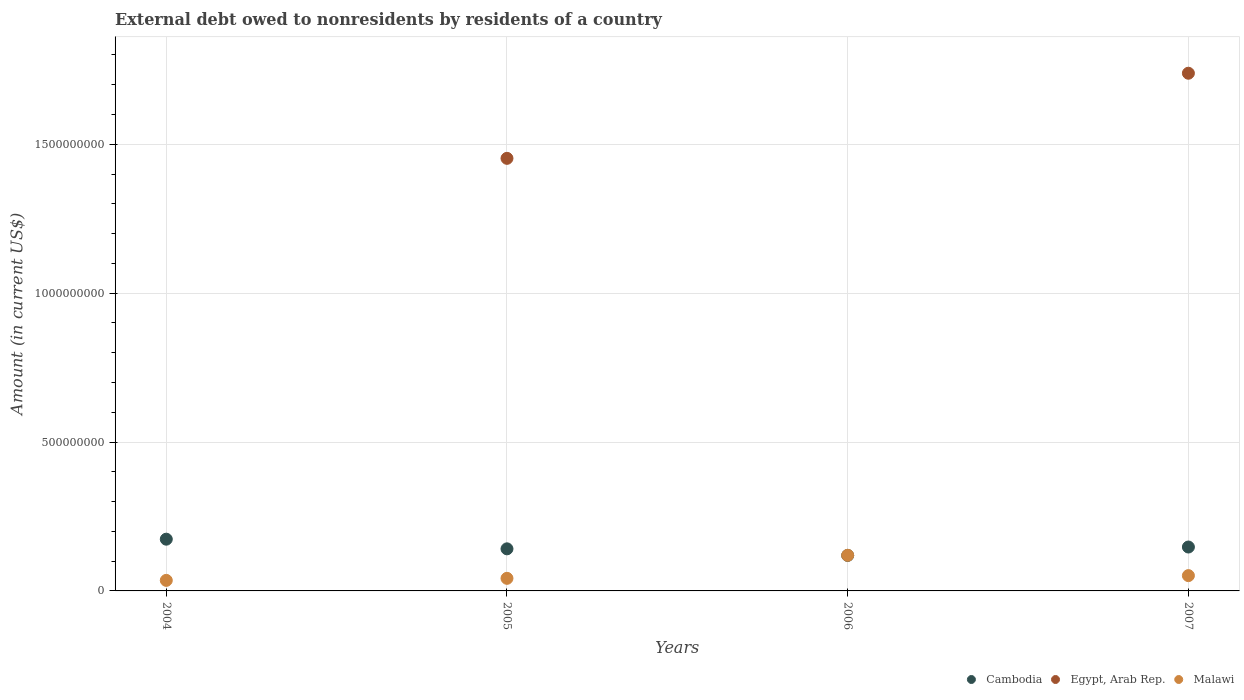What is the external debt owed by residents in Egypt, Arab Rep. in 2007?
Offer a very short reply. 1.74e+09. Across all years, what is the maximum external debt owed by residents in Malawi?
Give a very brief answer. 1.20e+08. Across all years, what is the minimum external debt owed by residents in Cambodia?
Offer a very short reply. 1.19e+08. In which year was the external debt owed by residents in Egypt, Arab Rep. maximum?
Your response must be concise. 2007. What is the total external debt owed by residents in Egypt, Arab Rep. in the graph?
Offer a very short reply. 3.19e+09. What is the difference between the external debt owed by residents in Cambodia in 2006 and that in 2007?
Offer a very short reply. -2.82e+07. What is the difference between the external debt owed by residents in Egypt, Arab Rep. in 2005 and the external debt owed by residents in Malawi in 2007?
Your answer should be compact. 1.40e+09. What is the average external debt owed by residents in Egypt, Arab Rep. per year?
Offer a very short reply. 7.98e+08. In the year 2007, what is the difference between the external debt owed by residents in Egypt, Arab Rep. and external debt owed by residents in Malawi?
Provide a succinct answer. 1.69e+09. In how many years, is the external debt owed by residents in Egypt, Arab Rep. greater than 1200000000 US$?
Your response must be concise. 2. What is the ratio of the external debt owed by residents in Malawi in 2006 to that in 2007?
Ensure brevity in your answer.  2.33. Is the external debt owed by residents in Cambodia in 2005 less than that in 2006?
Give a very brief answer. No. What is the difference between the highest and the second highest external debt owed by residents in Cambodia?
Your answer should be very brief. 2.63e+07. What is the difference between the highest and the lowest external debt owed by residents in Cambodia?
Make the answer very short. 5.45e+07. Is the sum of the external debt owed by residents in Cambodia in 2004 and 2005 greater than the maximum external debt owed by residents in Egypt, Arab Rep. across all years?
Your answer should be very brief. No. Does the external debt owed by residents in Malawi monotonically increase over the years?
Offer a terse response. No. How many dotlines are there?
Your answer should be compact. 3. What is the difference between two consecutive major ticks on the Y-axis?
Provide a short and direct response. 5.00e+08. Does the graph contain any zero values?
Offer a terse response. Yes. Does the graph contain grids?
Make the answer very short. Yes. Where does the legend appear in the graph?
Ensure brevity in your answer.  Bottom right. How many legend labels are there?
Give a very brief answer. 3. What is the title of the graph?
Provide a succinct answer. External debt owed to nonresidents by residents of a country. Does "Samoa" appear as one of the legend labels in the graph?
Ensure brevity in your answer.  No. What is the label or title of the X-axis?
Provide a succinct answer. Years. What is the Amount (in current US$) in Cambodia in 2004?
Make the answer very short. 1.74e+08. What is the Amount (in current US$) in Egypt, Arab Rep. in 2004?
Make the answer very short. 0. What is the Amount (in current US$) of Malawi in 2004?
Provide a short and direct response. 3.54e+07. What is the Amount (in current US$) of Cambodia in 2005?
Offer a very short reply. 1.41e+08. What is the Amount (in current US$) of Egypt, Arab Rep. in 2005?
Your answer should be very brief. 1.45e+09. What is the Amount (in current US$) of Malawi in 2005?
Give a very brief answer. 4.23e+07. What is the Amount (in current US$) in Cambodia in 2006?
Ensure brevity in your answer.  1.19e+08. What is the Amount (in current US$) of Malawi in 2006?
Provide a succinct answer. 1.20e+08. What is the Amount (in current US$) in Cambodia in 2007?
Offer a very short reply. 1.47e+08. What is the Amount (in current US$) in Egypt, Arab Rep. in 2007?
Your answer should be very brief. 1.74e+09. What is the Amount (in current US$) of Malawi in 2007?
Your response must be concise. 5.14e+07. Across all years, what is the maximum Amount (in current US$) in Cambodia?
Your response must be concise. 1.74e+08. Across all years, what is the maximum Amount (in current US$) in Egypt, Arab Rep.?
Offer a very short reply. 1.74e+09. Across all years, what is the maximum Amount (in current US$) in Malawi?
Your answer should be very brief. 1.20e+08. Across all years, what is the minimum Amount (in current US$) in Cambodia?
Give a very brief answer. 1.19e+08. Across all years, what is the minimum Amount (in current US$) in Egypt, Arab Rep.?
Give a very brief answer. 0. Across all years, what is the minimum Amount (in current US$) in Malawi?
Offer a very short reply. 3.54e+07. What is the total Amount (in current US$) of Cambodia in the graph?
Provide a short and direct response. 5.82e+08. What is the total Amount (in current US$) of Egypt, Arab Rep. in the graph?
Your answer should be very brief. 3.19e+09. What is the total Amount (in current US$) in Malawi in the graph?
Make the answer very short. 2.49e+08. What is the difference between the Amount (in current US$) of Cambodia in 2004 and that in 2005?
Provide a succinct answer. 3.24e+07. What is the difference between the Amount (in current US$) of Malawi in 2004 and that in 2005?
Offer a very short reply. -6.87e+06. What is the difference between the Amount (in current US$) of Cambodia in 2004 and that in 2006?
Provide a short and direct response. 5.45e+07. What is the difference between the Amount (in current US$) in Malawi in 2004 and that in 2006?
Your response must be concise. -8.43e+07. What is the difference between the Amount (in current US$) in Cambodia in 2004 and that in 2007?
Make the answer very short. 2.63e+07. What is the difference between the Amount (in current US$) in Malawi in 2004 and that in 2007?
Give a very brief answer. -1.60e+07. What is the difference between the Amount (in current US$) in Cambodia in 2005 and that in 2006?
Your answer should be compact. 2.21e+07. What is the difference between the Amount (in current US$) in Malawi in 2005 and that in 2006?
Provide a succinct answer. -7.74e+07. What is the difference between the Amount (in current US$) in Cambodia in 2005 and that in 2007?
Keep it short and to the point. -6.06e+06. What is the difference between the Amount (in current US$) in Egypt, Arab Rep. in 2005 and that in 2007?
Your response must be concise. -2.86e+08. What is the difference between the Amount (in current US$) of Malawi in 2005 and that in 2007?
Your answer should be very brief. -9.10e+06. What is the difference between the Amount (in current US$) in Cambodia in 2006 and that in 2007?
Make the answer very short. -2.82e+07. What is the difference between the Amount (in current US$) of Malawi in 2006 and that in 2007?
Give a very brief answer. 6.83e+07. What is the difference between the Amount (in current US$) of Cambodia in 2004 and the Amount (in current US$) of Egypt, Arab Rep. in 2005?
Offer a very short reply. -1.28e+09. What is the difference between the Amount (in current US$) in Cambodia in 2004 and the Amount (in current US$) in Malawi in 2005?
Your response must be concise. 1.31e+08. What is the difference between the Amount (in current US$) in Cambodia in 2004 and the Amount (in current US$) in Malawi in 2006?
Give a very brief answer. 5.41e+07. What is the difference between the Amount (in current US$) in Cambodia in 2004 and the Amount (in current US$) in Egypt, Arab Rep. in 2007?
Make the answer very short. -1.56e+09. What is the difference between the Amount (in current US$) in Cambodia in 2004 and the Amount (in current US$) in Malawi in 2007?
Provide a short and direct response. 1.22e+08. What is the difference between the Amount (in current US$) of Cambodia in 2005 and the Amount (in current US$) of Malawi in 2006?
Make the answer very short. 2.17e+07. What is the difference between the Amount (in current US$) of Egypt, Arab Rep. in 2005 and the Amount (in current US$) of Malawi in 2006?
Your answer should be compact. 1.33e+09. What is the difference between the Amount (in current US$) in Cambodia in 2005 and the Amount (in current US$) in Egypt, Arab Rep. in 2007?
Your answer should be very brief. -1.60e+09. What is the difference between the Amount (in current US$) in Cambodia in 2005 and the Amount (in current US$) in Malawi in 2007?
Offer a terse response. 9.00e+07. What is the difference between the Amount (in current US$) of Egypt, Arab Rep. in 2005 and the Amount (in current US$) of Malawi in 2007?
Offer a terse response. 1.40e+09. What is the difference between the Amount (in current US$) of Cambodia in 2006 and the Amount (in current US$) of Egypt, Arab Rep. in 2007?
Your response must be concise. -1.62e+09. What is the difference between the Amount (in current US$) in Cambodia in 2006 and the Amount (in current US$) in Malawi in 2007?
Give a very brief answer. 6.78e+07. What is the average Amount (in current US$) in Cambodia per year?
Keep it short and to the point. 1.45e+08. What is the average Amount (in current US$) of Egypt, Arab Rep. per year?
Offer a terse response. 7.98e+08. What is the average Amount (in current US$) in Malawi per year?
Your answer should be compact. 6.22e+07. In the year 2004, what is the difference between the Amount (in current US$) in Cambodia and Amount (in current US$) in Malawi?
Your answer should be compact. 1.38e+08. In the year 2005, what is the difference between the Amount (in current US$) of Cambodia and Amount (in current US$) of Egypt, Arab Rep.?
Offer a terse response. -1.31e+09. In the year 2005, what is the difference between the Amount (in current US$) of Cambodia and Amount (in current US$) of Malawi?
Your response must be concise. 9.91e+07. In the year 2005, what is the difference between the Amount (in current US$) in Egypt, Arab Rep. and Amount (in current US$) in Malawi?
Offer a very short reply. 1.41e+09. In the year 2006, what is the difference between the Amount (in current US$) in Cambodia and Amount (in current US$) in Malawi?
Your answer should be very brief. -4.47e+05. In the year 2007, what is the difference between the Amount (in current US$) in Cambodia and Amount (in current US$) in Egypt, Arab Rep.?
Your answer should be very brief. -1.59e+09. In the year 2007, what is the difference between the Amount (in current US$) of Cambodia and Amount (in current US$) of Malawi?
Your answer should be very brief. 9.60e+07. In the year 2007, what is the difference between the Amount (in current US$) of Egypt, Arab Rep. and Amount (in current US$) of Malawi?
Your answer should be compact. 1.69e+09. What is the ratio of the Amount (in current US$) in Cambodia in 2004 to that in 2005?
Keep it short and to the point. 1.23. What is the ratio of the Amount (in current US$) of Malawi in 2004 to that in 2005?
Your response must be concise. 0.84. What is the ratio of the Amount (in current US$) of Cambodia in 2004 to that in 2006?
Keep it short and to the point. 1.46. What is the ratio of the Amount (in current US$) of Malawi in 2004 to that in 2006?
Provide a succinct answer. 0.3. What is the ratio of the Amount (in current US$) of Cambodia in 2004 to that in 2007?
Provide a short and direct response. 1.18. What is the ratio of the Amount (in current US$) in Malawi in 2004 to that in 2007?
Your answer should be compact. 0.69. What is the ratio of the Amount (in current US$) of Cambodia in 2005 to that in 2006?
Your answer should be compact. 1.19. What is the ratio of the Amount (in current US$) in Malawi in 2005 to that in 2006?
Provide a short and direct response. 0.35. What is the ratio of the Amount (in current US$) in Cambodia in 2005 to that in 2007?
Offer a very short reply. 0.96. What is the ratio of the Amount (in current US$) of Egypt, Arab Rep. in 2005 to that in 2007?
Provide a short and direct response. 0.84. What is the ratio of the Amount (in current US$) in Malawi in 2005 to that in 2007?
Offer a terse response. 0.82. What is the ratio of the Amount (in current US$) in Cambodia in 2006 to that in 2007?
Give a very brief answer. 0.81. What is the ratio of the Amount (in current US$) of Malawi in 2006 to that in 2007?
Provide a succinct answer. 2.33. What is the difference between the highest and the second highest Amount (in current US$) in Cambodia?
Keep it short and to the point. 2.63e+07. What is the difference between the highest and the second highest Amount (in current US$) in Malawi?
Provide a succinct answer. 6.83e+07. What is the difference between the highest and the lowest Amount (in current US$) in Cambodia?
Your answer should be compact. 5.45e+07. What is the difference between the highest and the lowest Amount (in current US$) in Egypt, Arab Rep.?
Offer a very short reply. 1.74e+09. What is the difference between the highest and the lowest Amount (in current US$) in Malawi?
Your answer should be compact. 8.43e+07. 